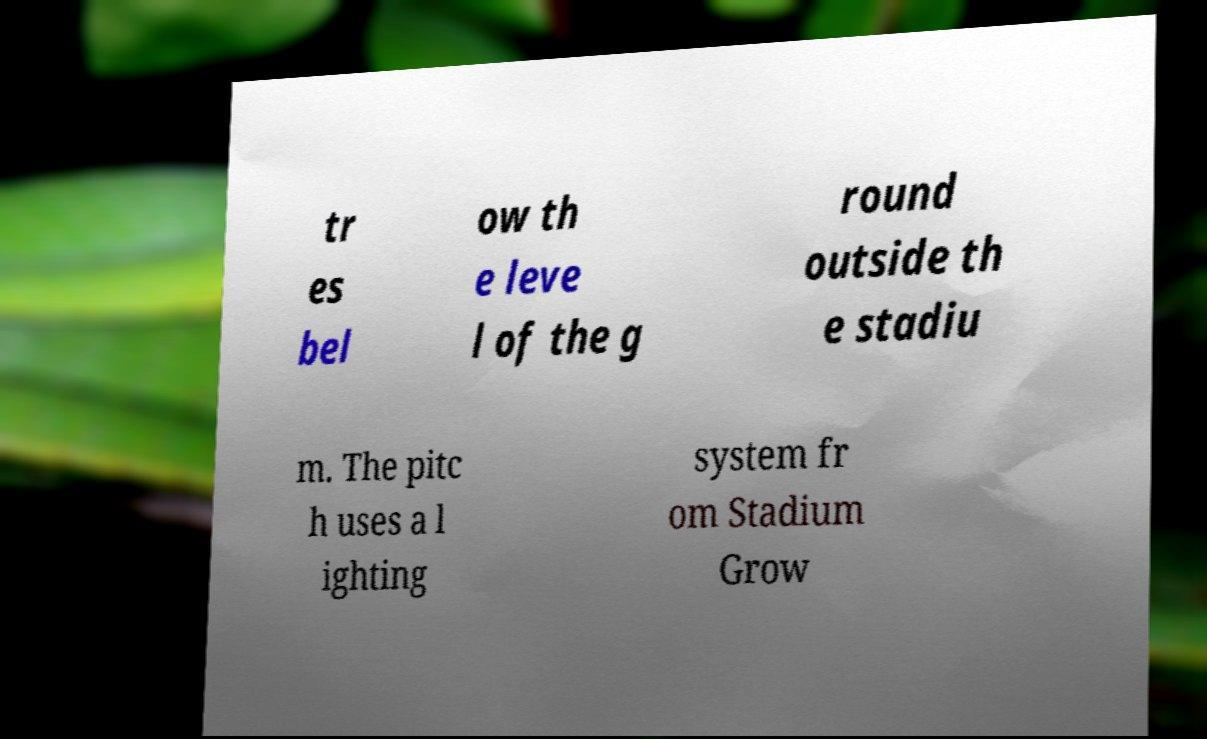For documentation purposes, I need the text within this image transcribed. Could you provide that? tr es bel ow th e leve l of the g round outside th e stadiu m. The pitc h uses a l ighting system fr om Stadium Grow 